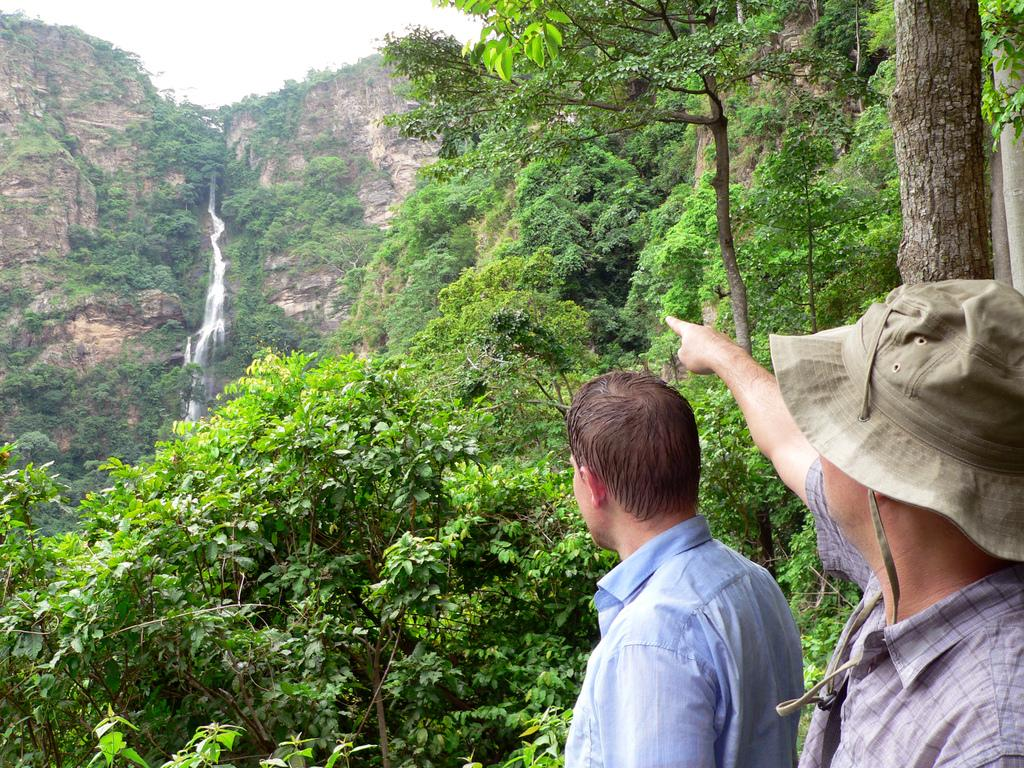What can be seen in the foreground of the image? There are persons standing in the front of the image. What is visible in the background of the image? There are trees and a mountain in the background of the image. What type of ice can be seen melting in the hands of the persons in the image? There is no ice present in the image, and the persons are not holding anything in their hands. 